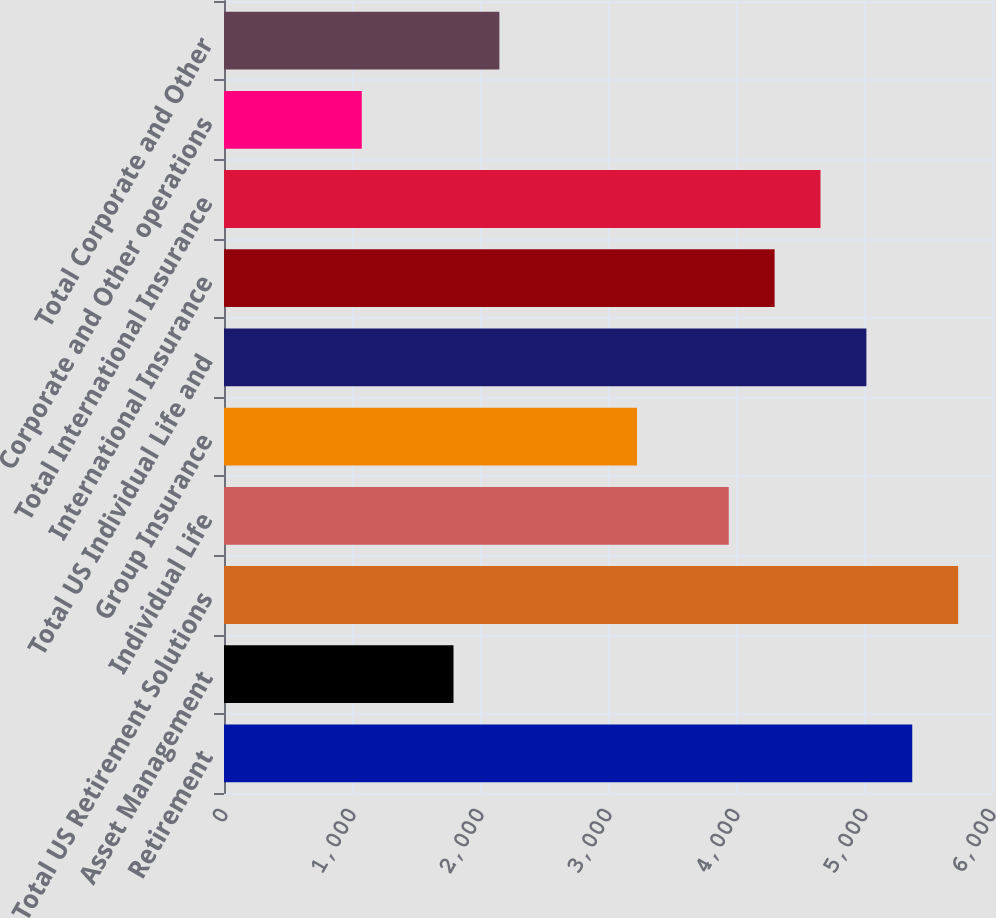Convert chart to OTSL. <chart><loc_0><loc_0><loc_500><loc_500><bar_chart><fcel>Retirement<fcel>Asset Management<fcel>Total US Retirement Solutions<fcel>Individual Life<fcel>Group Insurance<fcel>Total US Individual Life and<fcel>International Insurance<fcel>Total International Insurance<fcel>Corporate and Other operations<fcel>Total Corporate and Other<nl><fcel>5377<fcel>1793<fcel>5735.4<fcel>3943.4<fcel>3226.6<fcel>5018.6<fcel>4301.8<fcel>4660.2<fcel>1076.2<fcel>2151.4<nl></chart> 